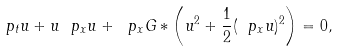Convert formula to latex. <formula><loc_0><loc_0><loc_500><loc_500>\ p _ { t } u + u \ p _ { x } u + \ p _ { x } G \ast \left ( u ^ { 2 } + \frac { 1 } { 2 } ( \ p _ { x } u ) ^ { 2 } \right ) = 0 ,</formula> 